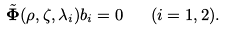Convert formula to latex. <formula><loc_0><loc_0><loc_500><loc_500>\tilde { \mathbf \Phi } ( \rho , \zeta , \lambda _ { i } ) b _ { i } = 0 \quad ( i = 1 , 2 ) .</formula> 